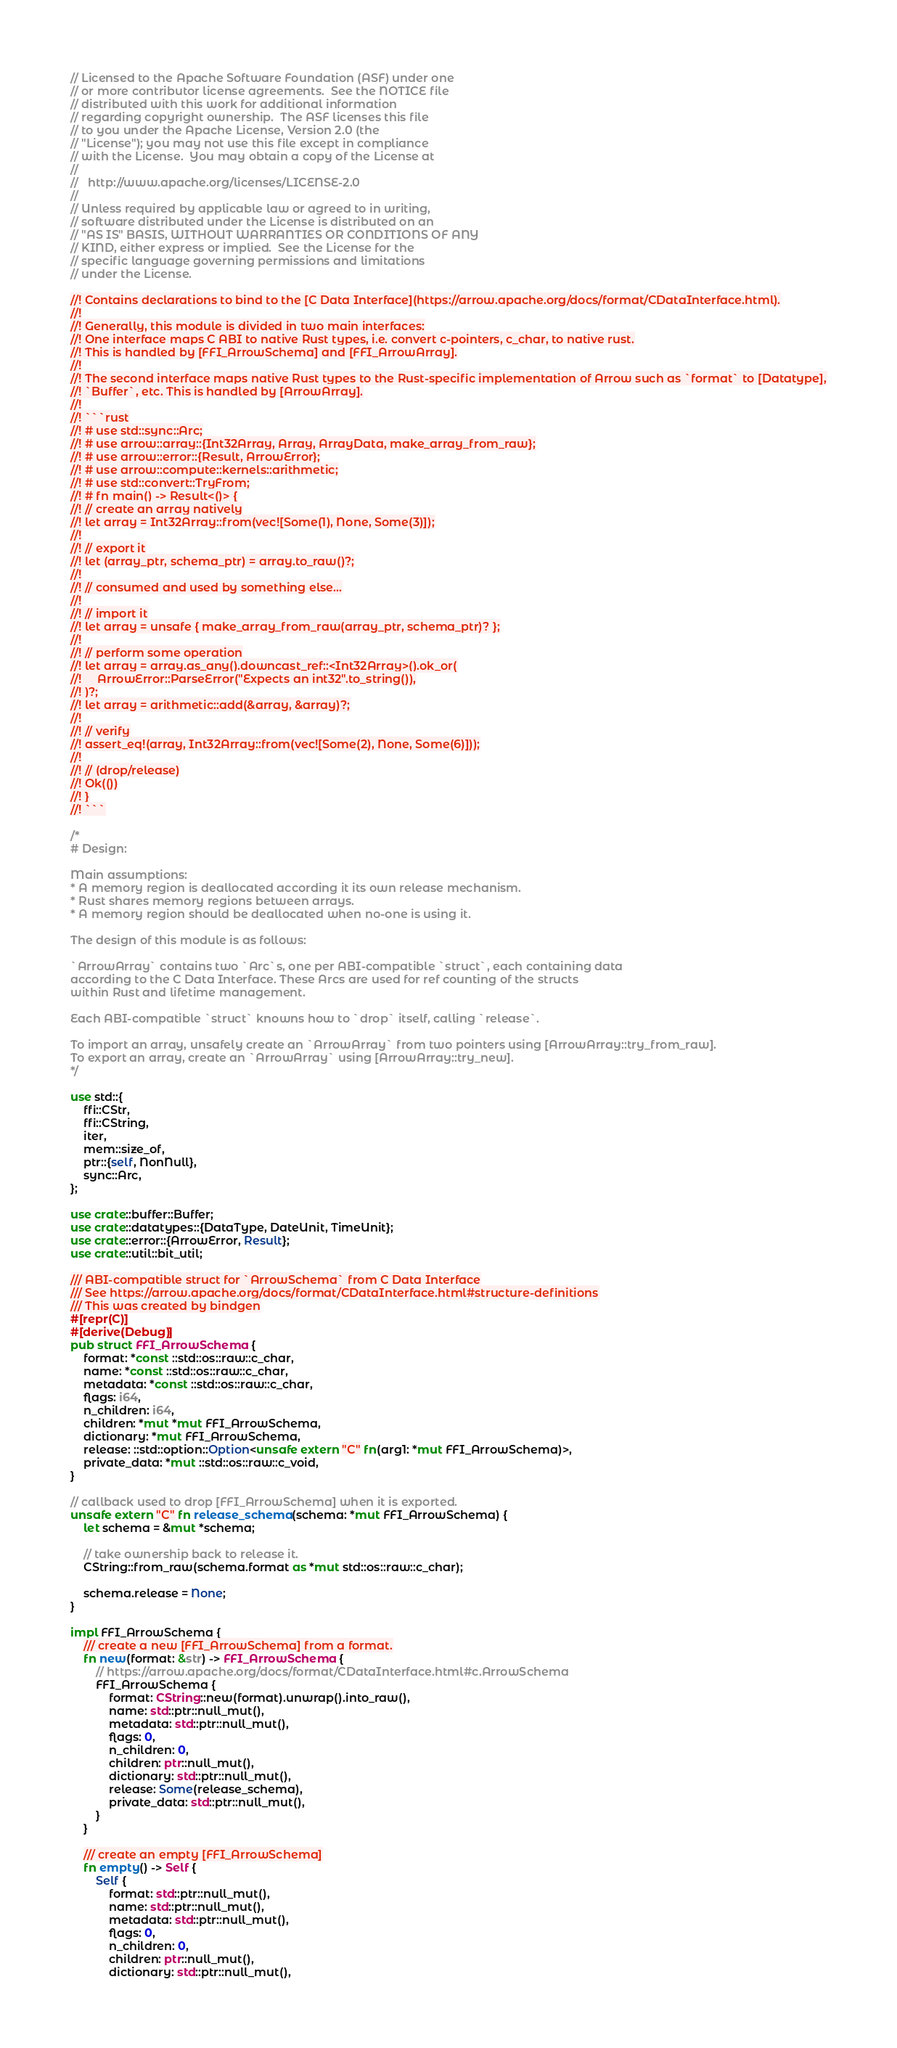Convert code to text. <code><loc_0><loc_0><loc_500><loc_500><_Rust_>// Licensed to the Apache Software Foundation (ASF) under one
// or more contributor license agreements.  See the NOTICE file
// distributed with this work for additional information
// regarding copyright ownership.  The ASF licenses this file
// to you under the Apache License, Version 2.0 (the
// "License"); you may not use this file except in compliance
// with the License.  You may obtain a copy of the License at
//
//   http://www.apache.org/licenses/LICENSE-2.0
//
// Unless required by applicable law or agreed to in writing,
// software distributed under the License is distributed on an
// "AS IS" BASIS, WITHOUT WARRANTIES OR CONDITIONS OF ANY
// KIND, either express or implied.  See the License for the
// specific language governing permissions and limitations
// under the License.

//! Contains declarations to bind to the [C Data Interface](https://arrow.apache.org/docs/format/CDataInterface.html).
//!
//! Generally, this module is divided in two main interfaces:
//! One interface maps C ABI to native Rust types, i.e. convert c-pointers, c_char, to native rust.
//! This is handled by [FFI_ArrowSchema] and [FFI_ArrowArray].
//!
//! The second interface maps native Rust types to the Rust-specific implementation of Arrow such as `format` to [Datatype],
//! `Buffer`, etc. This is handled by [ArrowArray].
//!
//! ```rust
//! # use std::sync::Arc;
//! # use arrow::array::{Int32Array, Array, ArrayData, make_array_from_raw};
//! # use arrow::error::{Result, ArrowError};
//! # use arrow::compute::kernels::arithmetic;
//! # use std::convert::TryFrom;
//! # fn main() -> Result<()> {
//! // create an array natively
//! let array = Int32Array::from(vec![Some(1), None, Some(3)]);
//!
//! // export it
//! let (array_ptr, schema_ptr) = array.to_raw()?;
//!
//! // consumed and used by something else...
//!
//! // import it
//! let array = unsafe { make_array_from_raw(array_ptr, schema_ptr)? };
//!
//! // perform some operation
//! let array = array.as_any().downcast_ref::<Int32Array>().ok_or(
//!     ArrowError::ParseError("Expects an int32".to_string()),
//! )?;
//! let array = arithmetic::add(&array, &array)?;
//!
//! // verify
//! assert_eq!(array, Int32Array::from(vec![Some(2), None, Some(6)]));
//!
//! // (drop/release)
//! Ok(())
//! }
//! ```

/*
# Design:

Main assumptions:
* A memory region is deallocated according it its own release mechanism.
* Rust shares memory regions between arrays.
* A memory region should be deallocated when no-one is using it.

The design of this module is as follows:

`ArrowArray` contains two `Arc`s, one per ABI-compatible `struct`, each containing data
according to the C Data Interface. These Arcs are used for ref counting of the structs
within Rust and lifetime management.

Each ABI-compatible `struct` knowns how to `drop` itself, calling `release`.

To import an array, unsafely create an `ArrowArray` from two pointers using [ArrowArray::try_from_raw].
To export an array, create an `ArrowArray` using [ArrowArray::try_new].
*/

use std::{
    ffi::CStr,
    ffi::CString,
    iter,
    mem::size_of,
    ptr::{self, NonNull},
    sync::Arc,
};

use crate::buffer::Buffer;
use crate::datatypes::{DataType, DateUnit, TimeUnit};
use crate::error::{ArrowError, Result};
use crate::util::bit_util;

/// ABI-compatible struct for `ArrowSchema` from C Data Interface
/// See https://arrow.apache.org/docs/format/CDataInterface.html#structure-definitions
/// This was created by bindgen
#[repr(C)]
#[derive(Debug)]
pub struct FFI_ArrowSchema {
    format: *const ::std::os::raw::c_char,
    name: *const ::std::os::raw::c_char,
    metadata: *const ::std::os::raw::c_char,
    flags: i64,
    n_children: i64,
    children: *mut *mut FFI_ArrowSchema,
    dictionary: *mut FFI_ArrowSchema,
    release: ::std::option::Option<unsafe extern "C" fn(arg1: *mut FFI_ArrowSchema)>,
    private_data: *mut ::std::os::raw::c_void,
}

// callback used to drop [FFI_ArrowSchema] when it is exported.
unsafe extern "C" fn release_schema(schema: *mut FFI_ArrowSchema) {
    let schema = &mut *schema;

    // take ownership back to release it.
    CString::from_raw(schema.format as *mut std::os::raw::c_char);

    schema.release = None;
}

impl FFI_ArrowSchema {
    /// create a new [FFI_ArrowSchema] from a format.
    fn new(format: &str) -> FFI_ArrowSchema {
        // https://arrow.apache.org/docs/format/CDataInterface.html#c.ArrowSchema
        FFI_ArrowSchema {
            format: CString::new(format).unwrap().into_raw(),
            name: std::ptr::null_mut(),
            metadata: std::ptr::null_mut(),
            flags: 0,
            n_children: 0,
            children: ptr::null_mut(),
            dictionary: std::ptr::null_mut(),
            release: Some(release_schema),
            private_data: std::ptr::null_mut(),
        }
    }

    /// create an empty [FFI_ArrowSchema]
    fn empty() -> Self {
        Self {
            format: std::ptr::null_mut(),
            name: std::ptr::null_mut(),
            metadata: std::ptr::null_mut(),
            flags: 0,
            n_children: 0,
            children: ptr::null_mut(),
            dictionary: std::ptr::null_mut(),</code> 